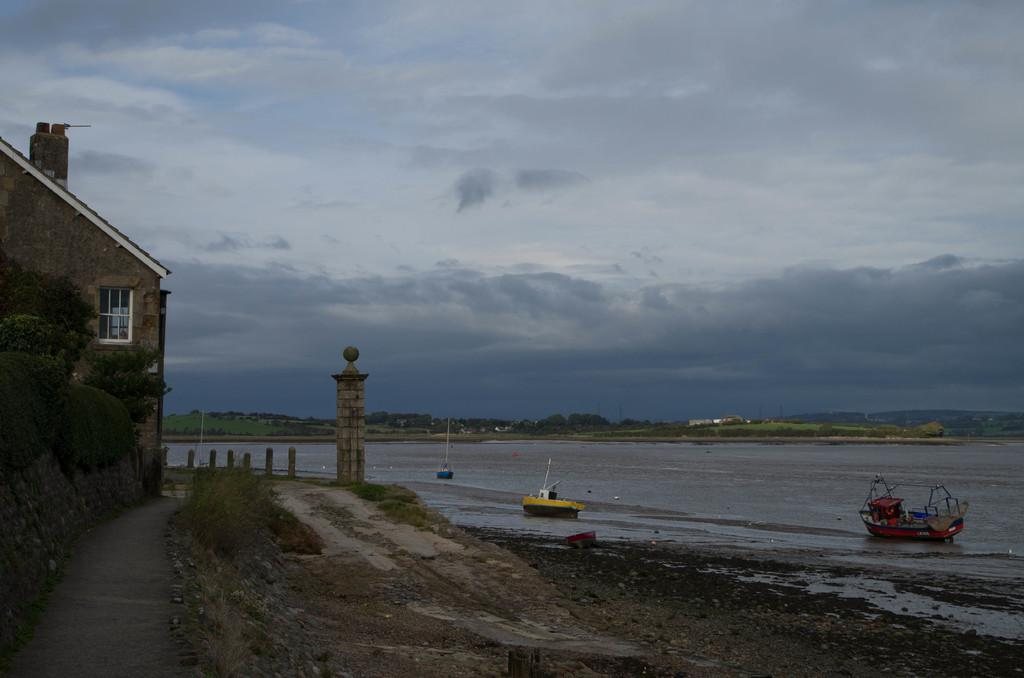What type of structures can be seen in the image? There are buildings in the image. What other natural elements are present in the image? There are trees in the image. What is on the water in the image? There are ships on the water in the image. What tall structure can be seen in the image? There is a tower in the image. What part of the natural environment is visible in the image? The sky is visible in the image. What can be observed in the sky? There are clouds in the sky. What type of doctor is present in the image? There is no doctor present in the image. How many clovers can be seen growing in the image? There are no clovers present in the image. 